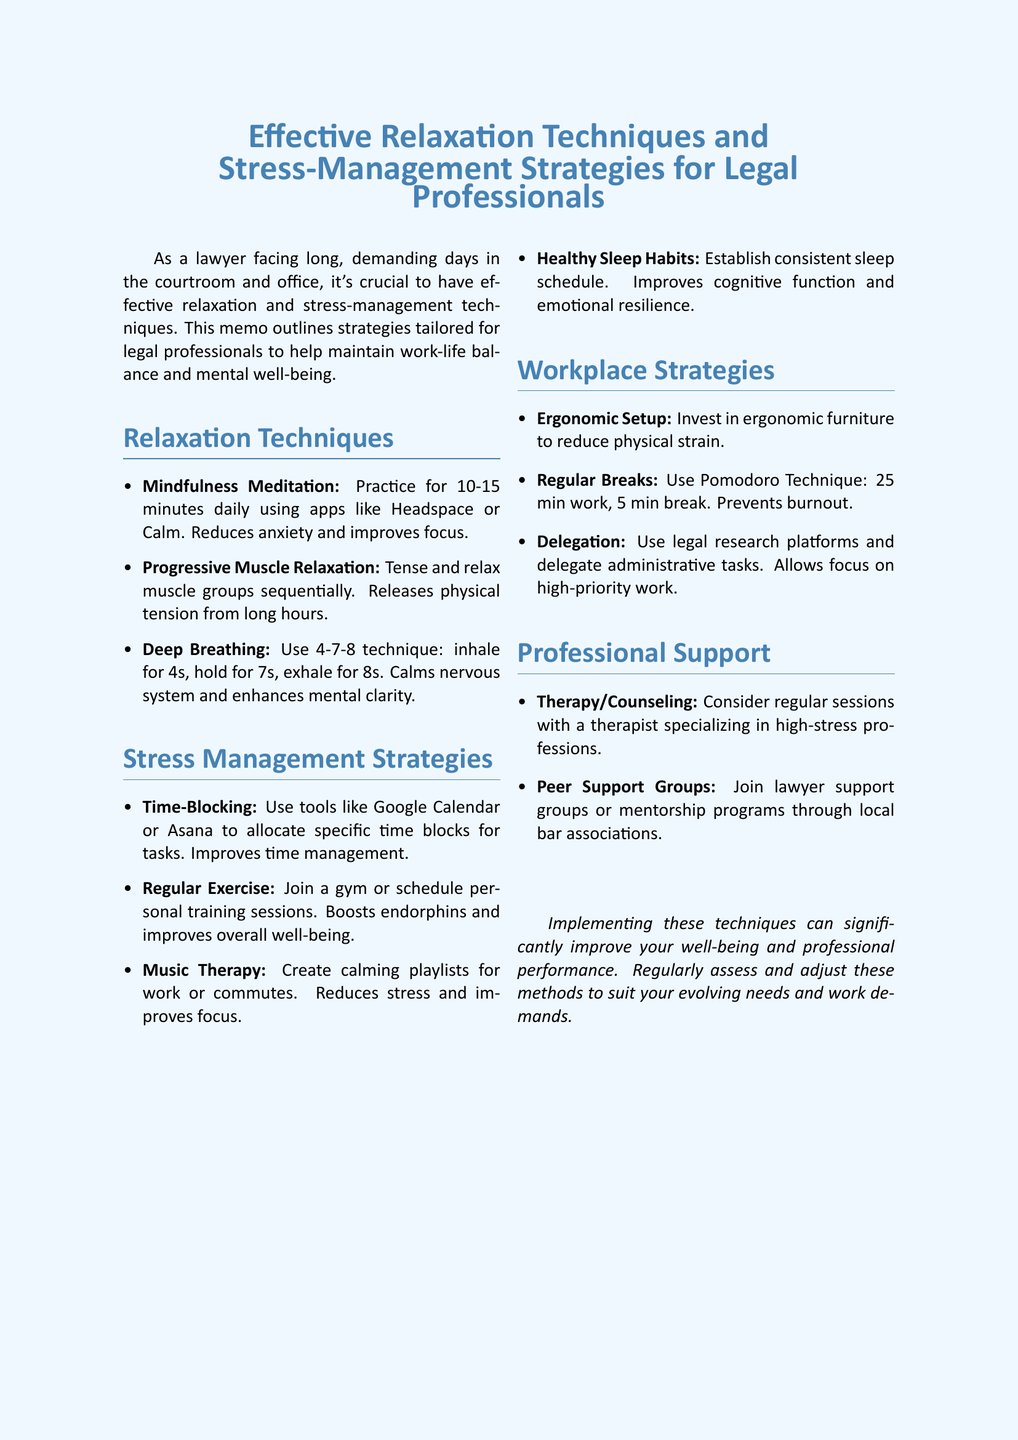What is the title of the memo? The title of the memo is presented prominently at the beginning, indicating the subject of relaxation techniques and stress-management strategies.
Answer: Effective Relaxation Techniques and Stress-Management Strategies for Legal Professionals How many relaxation techniques are listed? The list of relaxation techniques includes a specific number of items as outlined in the document.
Answer: 3 What is one benefit of Deep Breathing Exercises? The document states specific benefits for each technique, highlighting advantages for legal professionals in managing stress and improving concentration.
Answer: Calms the nervous system What tool is suggested for Time-Blocking? The memo provides recommendations for tools that can be utilized to improve time management among legal professionals.
Answer: Google Calendar What is one strategy mentioned for maintaining Healthy Sleep Habits? The document outlines key strategies to enhance sleep quality, which is vital for legal professionals.
Answer: Establish a consistent sleep schedule What type of professional support is recommended for stress management? The memo emphasizes resources that contribute to the mental well-being of legal professionals, including specific types of support available.
Answer: Therapy or Counseling What is the Pomodoro Technique described as? The workplace strategies section describes specific methods for improving productivity and mental health, highlighting distinctive techniques like the Pomodoro Technique.
Answer: 25 min work, 5 min break What is one benefit of Regular Exercise? The benefits associated with each strategy are detailed, providing insights into the importance of physical health for legal professionals.
Answer: Boosts endorphins 